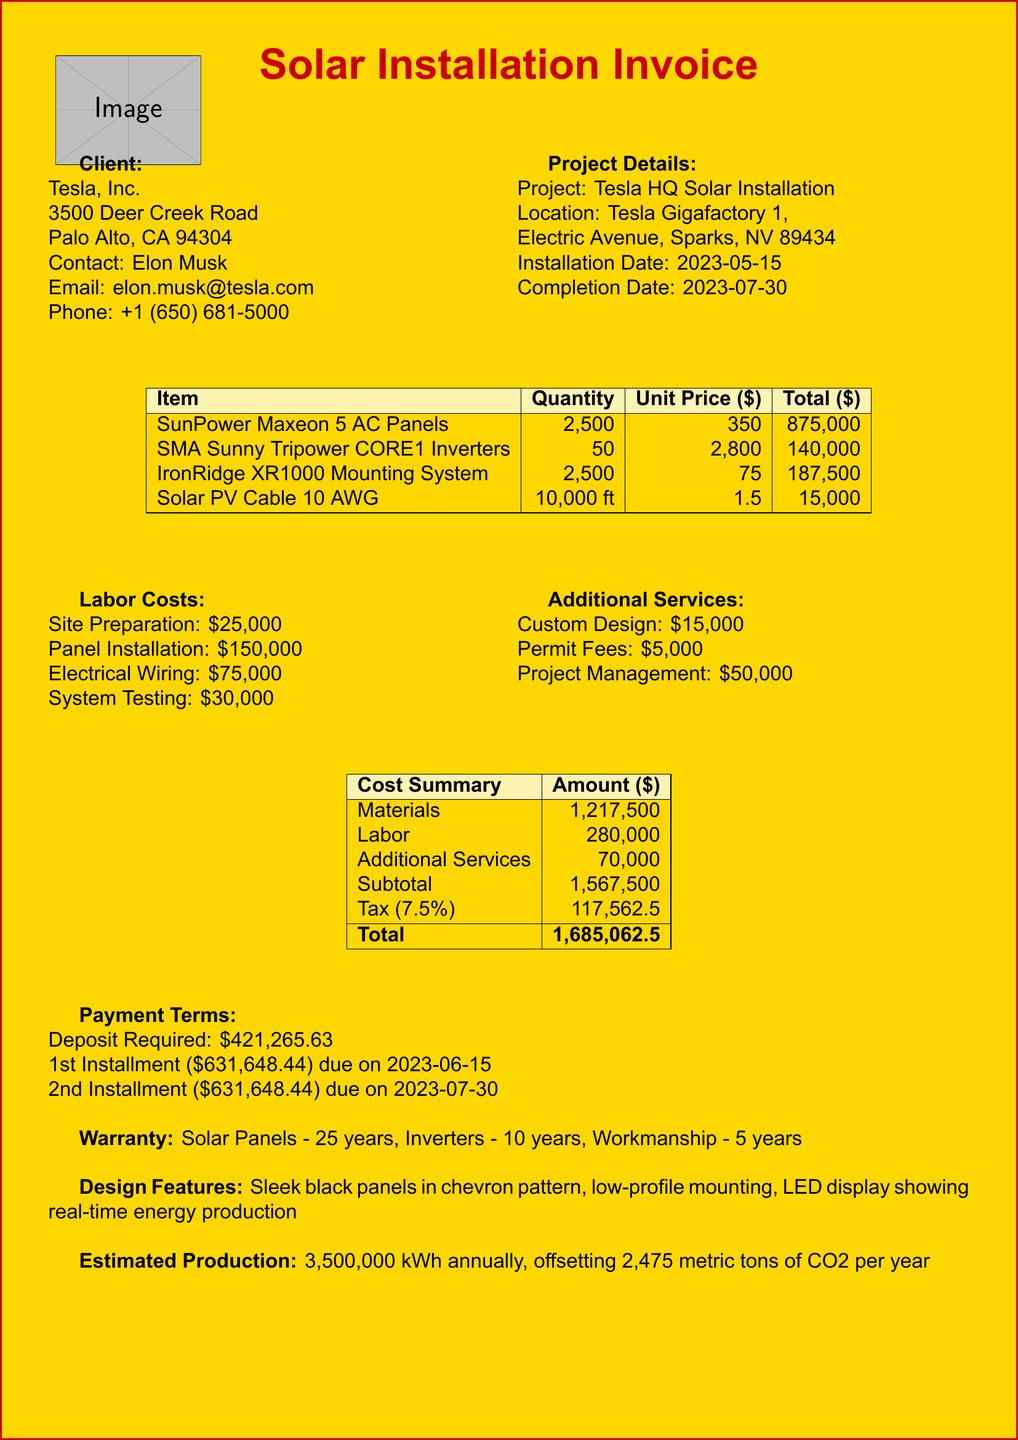what is the total cost of materials? The total cost of materials is listed in the summary table as $1,217,500.
Answer: $1,217,500 who is the contact person for this project? The document states that the contact person is Elon Musk.
Answer: Elon Musk how many solar panels were installed? The number of solar panels is explicitly stated in the solar panel section as 2,500.
Answer: 2,500 when is the first installment due? The first installment due date is mentioned as 2023-06-15.
Answer: 2023-06-15 what is the warranty period for the solar panels? The warranty for the solar panels is specified as 25 years.
Answer: 25 years what is the total tax amount? The total tax amount is provided in the cost summary as $117,562.50.
Answer: $117,562.50 which mounting system was used? The document specifies the mounting system used as IronRidge XR1000.
Answer: IronRidge XR1000 what is the estimated annual energy output? The estimated annual energy output is listed as 3,500,000 kWh.
Answer: 3,500,000 kWh what is the total cost including tax? The total cost, including tax, is provided as $1,685,062.50.
Answer: $1,685,062.50 